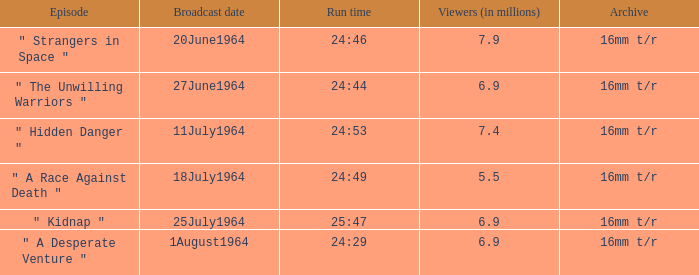What is the running time when there were 24:53. 